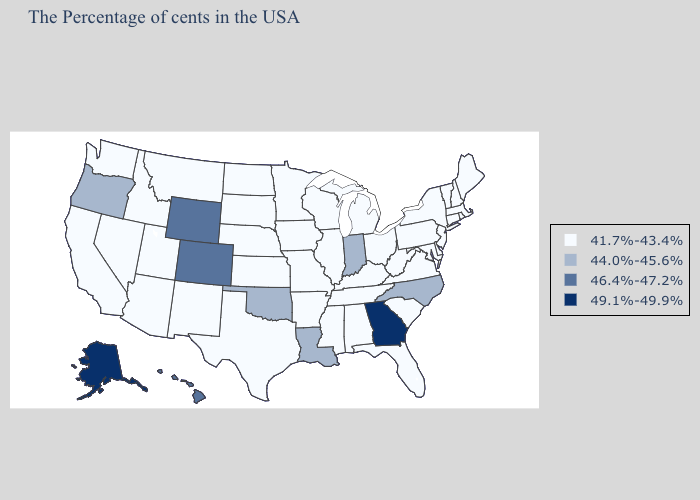Which states hav the highest value in the South?
Write a very short answer. Georgia. What is the lowest value in the South?
Answer briefly. 41.7%-43.4%. Does Minnesota have the lowest value in the MidWest?
Concise answer only. Yes. Does Oklahoma have the lowest value in the South?
Short answer required. No. What is the highest value in states that border Delaware?
Keep it brief. 41.7%-43.4%. Among the states that border Louisiana , which have the highest value?
Keep it brief. Mississippi, Arkansas, Texas. What is the highest value in states that border Illinois?
Write a very short answer. 44.0%-45.6%. What is the highest value in states that border Arkansas?
Write a very short answer. 44.0%-45.6%. Which states have the highest value in the USA?
Concise answer only. Georgia, Alaska. What is the value of New Jersey?
Give a very brief answer. 41.7%-43.4%. What is the value of West Virginia?
Short answer required. 41.7%-43.4%. What is the value of Illinois?
Concise answer only. 41.7%-43.4%. What is the value of Pennsylvania?
Answer briefly. 41.7%-43.4%. Name the states that have a value in the range 46.4%-47.2%?
Write a very short answer. Wyoming, Colorado, Hawaii. Name the states that have a value in the range 41.7%-43.4%?
Write a very short answer. Maine, Massachusetts, Rhode Island, New Hampshire, Vermont, Connecticut, New York, New Jersey, Delaware, Maryland, Pennsylvania, Virginia, South Carolina, West Virginia, Ohio, Florida, Michigan, Kentucky, Alabama, Tennessee, Wisconsin, Illinois, Mississippi, Missouri, Arkansas, Minnesota, Iowa, Kansas, Nebraska, Texas, South Dakota, North Dakota, New Mexico, Utah, Montana, Arizona, Idaho, Nevada, California, Washington. 